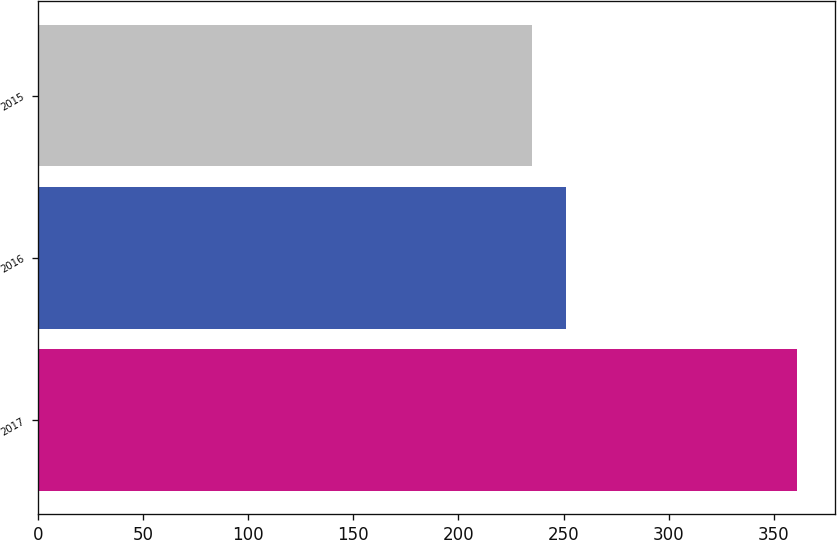<chart> <loc_0><loc_0><loc_500><loc_500><bar_chart><fcel>2017<fcel>2016<fcel>2015<nl><fcel>361<fcel>251<fcel>235<nl></chart> 